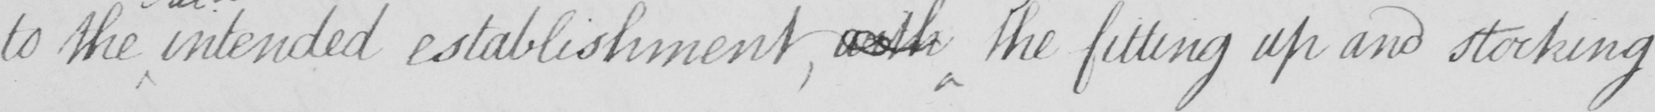Can you read and transcribe this handwriting? to the intended establishment  , with the fitting up and stocking 